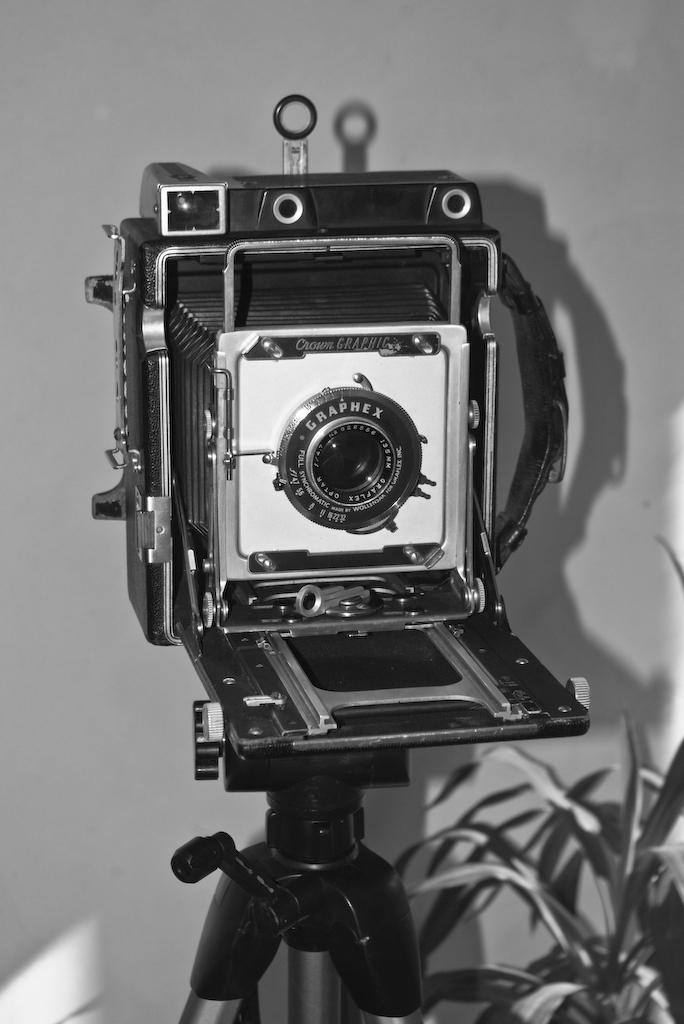What is the color scheme of the image? The image is black and white. What object can be seen in the image that is related to photography? There is a camera stand in the image. What type of living organism is present in the image? There is a plant in the image. What can be seen in the background of the image? There is a wall in the background of the image. How many cherries are hanging from the plant in the image? There are no cherries present in the image; it only features a plant. What type of regret can be seen on the wall in the image? There is no regret visible in the image; the wall is simply a part of the background. 